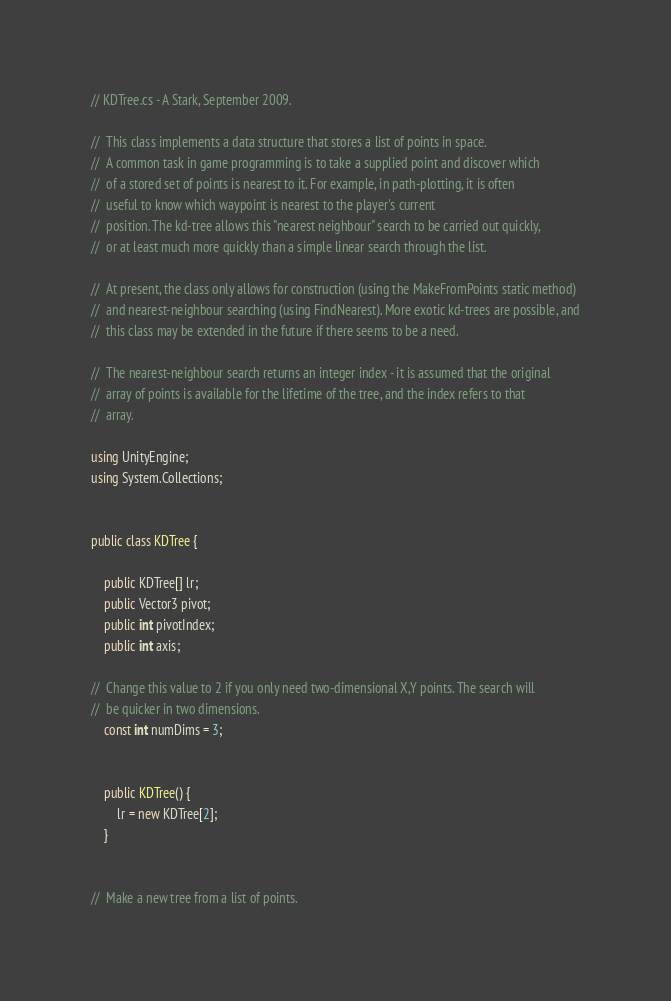Convert code to text. <code><loc_0><loc_0><loc_500><loc_500><_C#_>// KDTree.cs - A Stark, September 2009.

//	This class implements a data structure that stores a list of points in space.
//	A common task in game programming is to take a supplied point and discover which
//	of a stored set of points is nearest to it. For example, in path-plotting, it is often
//	useful to know which waypoint is nearest to the player's current
//	position. The kd-tree allows this "nearest neighbour" search to be carried out quickly,
//	or at least much more quickly than a simple linear search through the list.

//	At present, the class only allows for construction (using the MakeFromPoints static method)
//	and nearest-neighbour searching (using FindNearest). More exotic kd-trees are possible, and
//	this class may be extended in the future if there seems to be a need.

//	The nearest-neighbour search returns an integer index - it is assumed that the original
//	array of points is available for the lifetime of the tree, and the index refers to that
//	array.

using UnityEngine;
using System.Collections;


public class KDTree {
	
	public KDTree[] lr;
	public Vector3 pivot;
	public int pivotIndex;
	public int axis;
	
//	Change this value to 2 if you only need two-dimensional X,Y points. The search will
//	be quicker in two dimensions.
	const int numDims = 3;
	
	
	public KDTree() {
		lr = new KDTree[2];
	}
	

//	Make a new tree from a list of points.</code> 